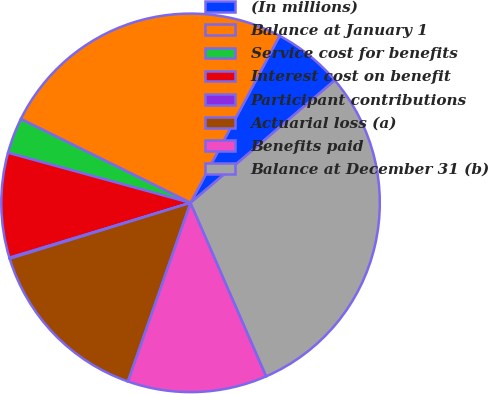Convert chart to OTSL. <chart><loc_0><loc_0><loc_500><loc_500><pie_chart><fcel>(In millions)<fcel>Balance at January 1<fcel>Service cost for benefits<fcel>Interest cost on benefit<fcel>Participant contributions<fcel>Actuarial loss (a)<fcel>Benefits paid<fcel>Balance at December 31 (b)<nl><fcel>6.0%<fcel>25.49%<fcel>3.04%<fcel>8.95%<fcel>0.08%<fcel>14.87%<fcel>11.91%<fcel>29.66%<nl></chart> 